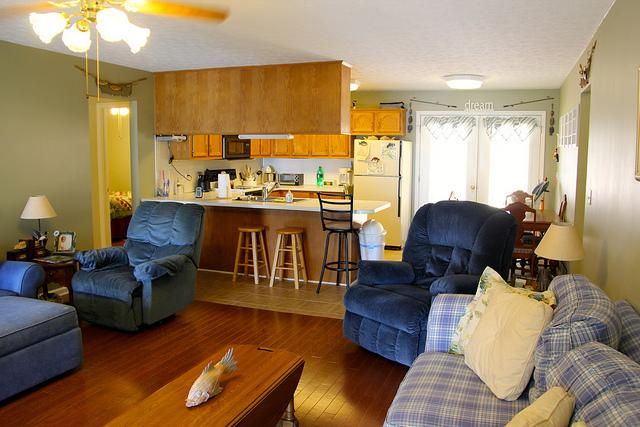What is on the brown table near the couch? Please explain your reasoning. fish. The table has a fish. 